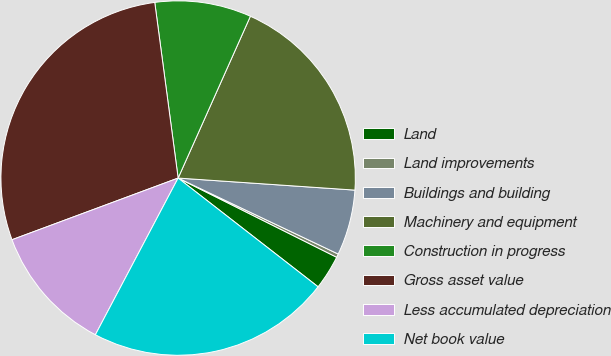<chart> <loc_0><loc_0><loc_500><loc_500><pie_chart><fcel>Land<fcel>Land improvements<fcel>Buildings and building<fcel>Machinery and equipment<fcel>Construction in progress<fcel>Gross asset value<fcel>Less accumulated depreciation<fcel>Net book value<nl><fcel>3.14%<fcel>0.32%<fcel>5.97%<fcel>19.4%<fcel>8.79%<fcel>28.55%<fcel>11.61%<fcel>22.22%<nl></chart> 